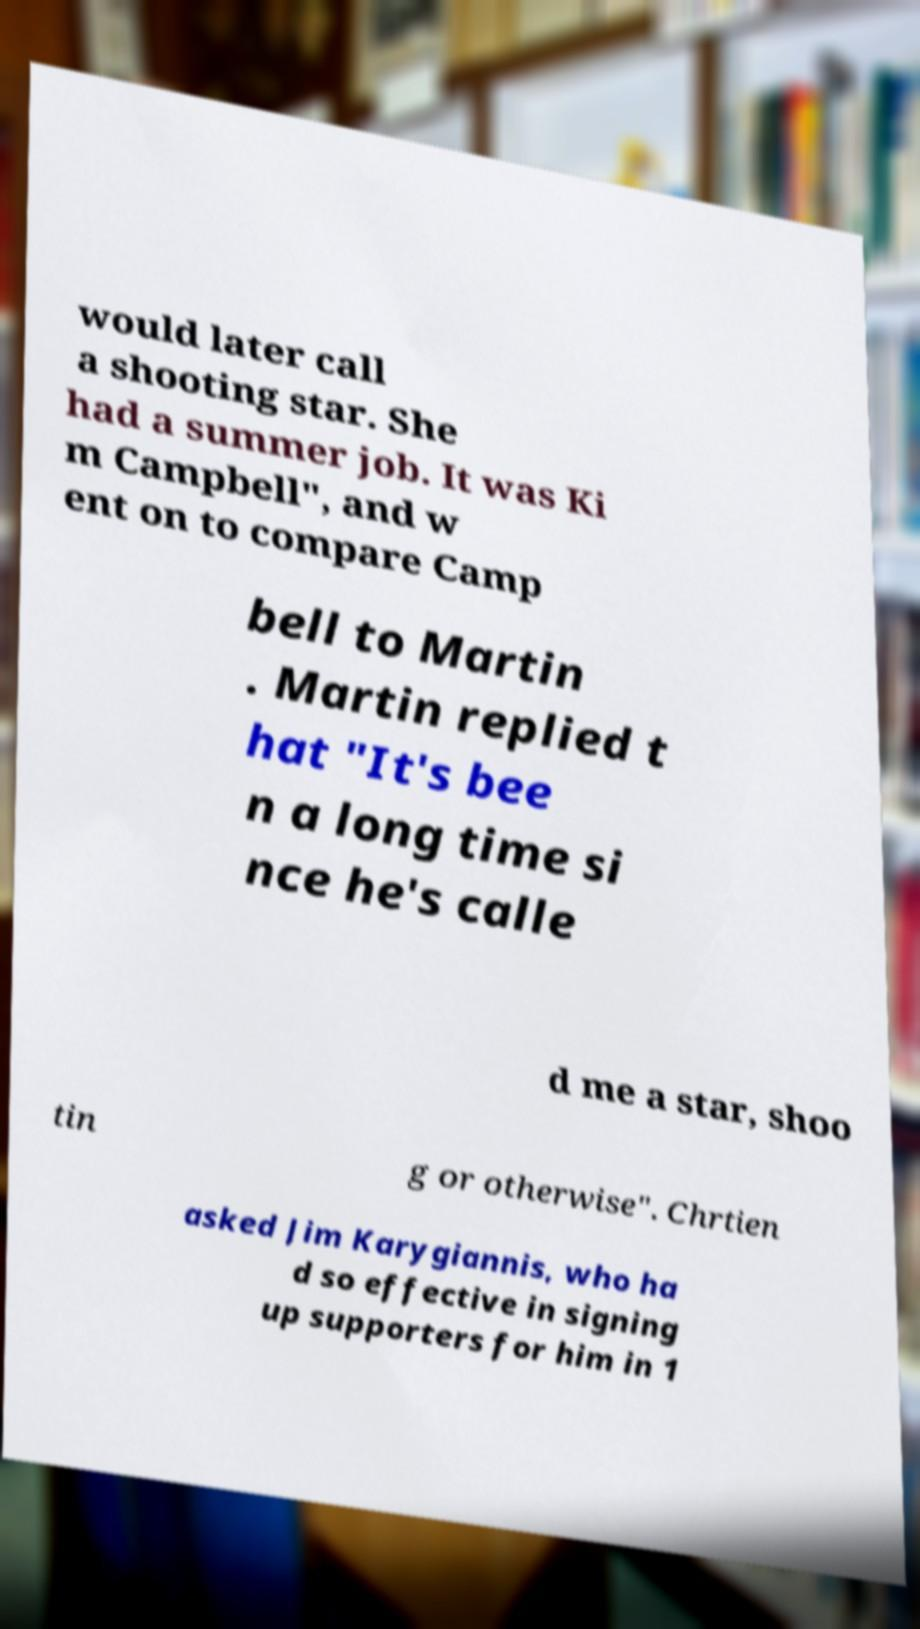Can you read and provide the text displayed in the image?This photo seems to have some interesting text. Can you extract and type it out for me? would later call a shooting star. She had a summer job. It was Ki m Campbell", and w ent on to compare Camp bell to Martin . Martin replied t hat "It's bee n a long time si nce he's calle d me a star, shoo tin g or otherwise". Chrtien asked Jim Karygiannis, who ha d so effective in signing up supporters for him in 1 